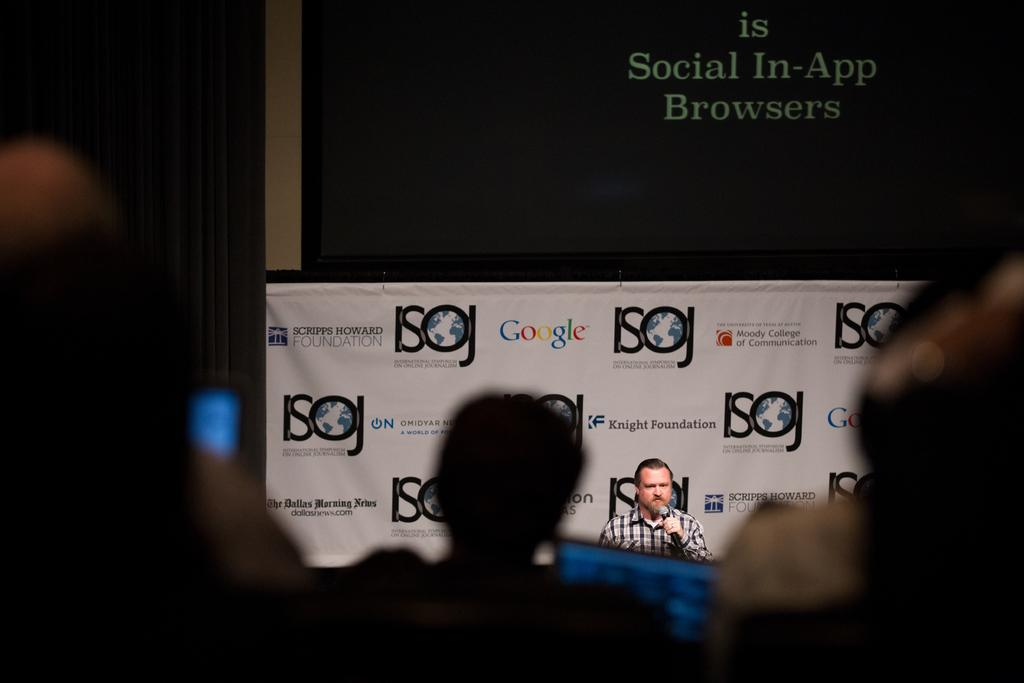How many people are in the image? There are people in the image, but the exact number is not specified. What is one person doing in the image? One person is holding a microphone. What can be seen in the background of the image? There is a banner with text in the background. What is on top of the banner in the image? There is a screen with text on top of the banner. What type of map can be seen on the screen in the image? There is no map present on the screen in the image; it displays text instead. What is the air quality like in the image? The facts provided do not give any information about the air quality in the image. 